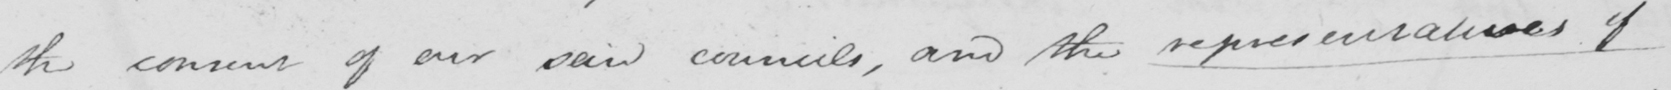Transcribe the text shown in this historical manuscript line. the consent of our said councils , and the representatives of 